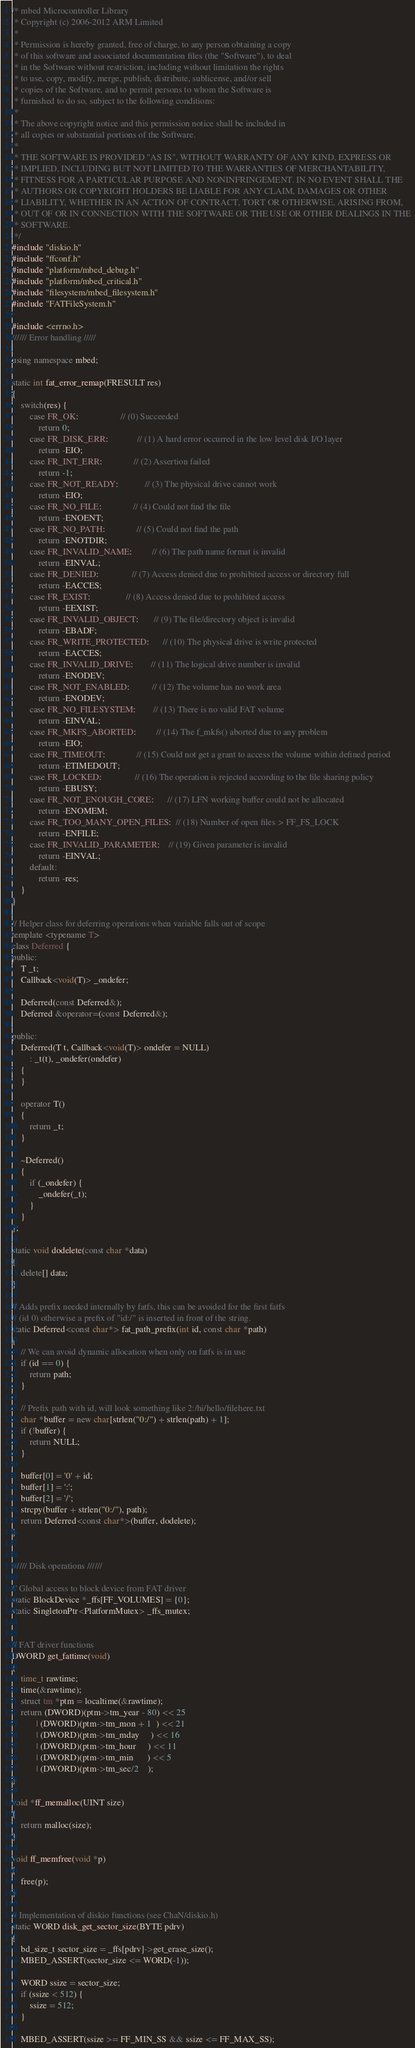<code> <loc_0><loc_0><loc_500><loc_500><_C++_>/* mbed Microcontroller Library
 * Copyright (c) 2006-2012 ARM Limited
 *
 * Permission is hereby granted, free of charge, to any person obtaining a copy
 * of this software and associated documentation files (the "Software"), to deal
 * in the Software without restriction, including without limitation the rights
 * to use, copy, modify, merge, publish, distribute, sublicense, and/or sell
 * copies of the Software, and to permit persons to whom the Software is
 * furnished to do so, subject to the following conditions:
 *
 * The above copyright notice and this permission notice shall be included in
 * all copies or substantial portions of the Software.
 *
 * THE SOFTWARE IS PROVIDED "AS IS", WITHOUT WARRANTY OF ANY KIND, EXPRESS OR
 * IMPLIED, INCLUDING BUT NOT LIMITED TO THE WARRANTIES OF MERCHANTABILITY,
 * FITNESS FOR A PARTICULAR PURPOSE AND NONINFRINGEMENT. IN NO EVENT SHALL THE
 * AUTHORS OR COPYRIGHT HOLDERS BE LIABLE FOR ANY CLAIM, DAMAGES OR OTHER
 * LIABILITY, WHETHER IN AN ACTION OF CONTRACT, TORT OR OTHERWISE, ARISING FROM,
 * OUT OF OR IN CONNECTION WITH THE SOFTWARE OR THE USE OR OTHER DEALINGS IN THE
 * SOFTWARE.
 */
#include "diskio.h"
#include "ffconf.h"
#include "platform/mbed_debug.h"
#include "platform/mbed_critical.h"
#include "filesystem/mbed_filesystem.h"
#include "FATFileSystem.h"

#include <errno.h>
////// Error handling /////

using namespace mbed;

static int fat_error_remap(FRESULT res)
{
    switch(res) {
        case FR_OK:                   // (0) Succeeded
            return 0;
        case FR_DISK_ERR:             // (1) A hard error occurred in the low level disk I/O layer
            return -EIO;
        case FR_INT_ERR:              // (2) Assertion failed
            return -1;
        case FR_NOT_READY:            // (3) The physical drive cannot work
            return -EIO;
        case FR_NO_FILE:              // (4) Could not find the file
            return -ENOENT;
        case FR_NO_PATH:              // (5) Could not find the path
            return -ENOTDIR;
        case FR_INVALID_NAME:         // (6) The path name format is invalid
            return -EINVAL;
        case FR_DENIED:               // (7) Access denied due to prohibited access or directory full
            return -EACCES;
        case FR_EXIST:                // (8) Access denied due to prohibited access
            return -EEXIST;
        case FR_INVALID_OBJECT:       // (9) The file/directory object is invalid
            return -EBADF;
        case FR_WRITE_PROTECTED:      // (10) The physical drive is write protected
            return -EACCES;
        case FR_INVALID_DRIVE:        // (11) The logical drive number is invalid
            return -ENODEV;
        case FR_NOT_ENABLED:          // (12) The volume has no work area
            return -ENODEV;
        case FR_NO_FILESYSTEM:        // (13) There is no valid FAT volume
            return -EINVAL;
        case FR_MKFS_ABORTED:         // (14) The f_mkfs() aborted due to any problem
            return -EIO;
        case FR_TIMEOUT:              // (15) Could not get a grant to access the volume within defined period
            return -ETIMEDOUT;
        case FR_LOCKED:               // (16) The operation is rejected according to the file sharing policy
            return -EBUSY;
        case FR_NOT_ENOUGH_CORE:      // (17) LFN working buffer could not be allocated
            return -ENOMEM;
        case FR_TOO_MANY_OPEN_FILES:  // (18) Number of open files > FF_FS_LOCK
            return -ENFILE;
        case FR_INVALID_PARAMETER:    // (19) Given parameter is invalid
            return -EINVAL;
        default:
            return -res;
    }
}

// Helper class for deferring operations when variable falls out of scope
template <typename T>
class Deferred {
public:
    T _t;
    Callback<void(T)> _ondefer;

    Deferred(const Deferred&);
    Deferred &operator=(const Deferred&);

public:
    Deferred(T t, Callback<void(T)> ondefer = NULL)
        : _t(t), _ondefer(ondefer)
    {
    }

    operator T()
    {
        return _t;
    }

    ~Deferred()
    {
        if (_ondefer) {
            _ondefer(_t);
        }
    }
};

static void dodelete(const char *data)
{
    delete[] data;
}

// Adds prefix needed internally by fatfs, this can be avoided for the first fatfs
// (id 0) otherwise a prefix of "id:/" is inserted in front of the string.
static Deferred<const char*> fat_path_prefix(int id, const char *path)
{
    // We can avoid dynamic allocation when only on fatfs is in use
    if (id == 0) {
        return path;
    }

    // Prefix path with id, will look something like 2:/hi/hello/filehere.txt
    char *buffer = new char[strlen("0:/") + strlen(path) + 1];
    if (!buffer) {
        return NULL;
    }

    buffer[0] = '0' + id;
    buffer[1] = ':';
    buffer[2] = '/';
    strcpy(buffer + strlen("0:/"), path);
    return Deferred<const char*>(buffer, dodelete);
}


////// Disk operations //////

// Global access to block device from FAT driver
static BlockDevice *_ffs[FF_VOLUMES] = {0};
static SingletonPtr<PlatformMutex> _ffs_mutex;


// FAT driver functions
DWORD get_fattime(void)
{
    time_t rawtime;
    time(&rawtime);
    struct tm *ptm = localtime(&rawtime);
    return (DWORD)(ptm->tm_year - 80) << 25
           | (DWORD)(ptm->tm_mon + 1  ) << 21
           | (DWORD)(ptm->tm_mday     ) << 16
           | (DWORD)(ptm->tm_hour     ) << 11
           | (DWORD)(ptm->tm_min      ) << 5
           | (DWORD)(ptm->tm_sec/2    );
}

void *ff_memalloc(UINT size)
{
    return malloc(size);
}

void ff_memfree(void *p)
{
    free(p);
}

// Implementation of diskio functions (see ChaN/diskio.h)
static WORD disk_get_sector_size(BYTE pdrv)
{
    bd_size_t sector_size = _ffs[pdrv]->get_erase_size();
    MBED_ASSERT(sector_size <= WORD(-1));

    WORD ssize = sector_size;
    if (ssize < 512) {
        ssize = 512;
    }

    MBED_ASSERT(ssize >= FF_MIN_SS && ssize <= FF_MAX_SS);</code> 